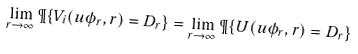Convert formula to latex. <formula><loc_0><loc_0><loc_500><loc_500>\lim _ { r \rightarrow \infty } \P \{ V _ { i } ( u \phi _ { r } , r ) = D _ { r } \} = \lim _ { r \rightarrow \infty } \P \{ U ( u \phi _ { r } , r ) = D _ { r } \}</formula> 